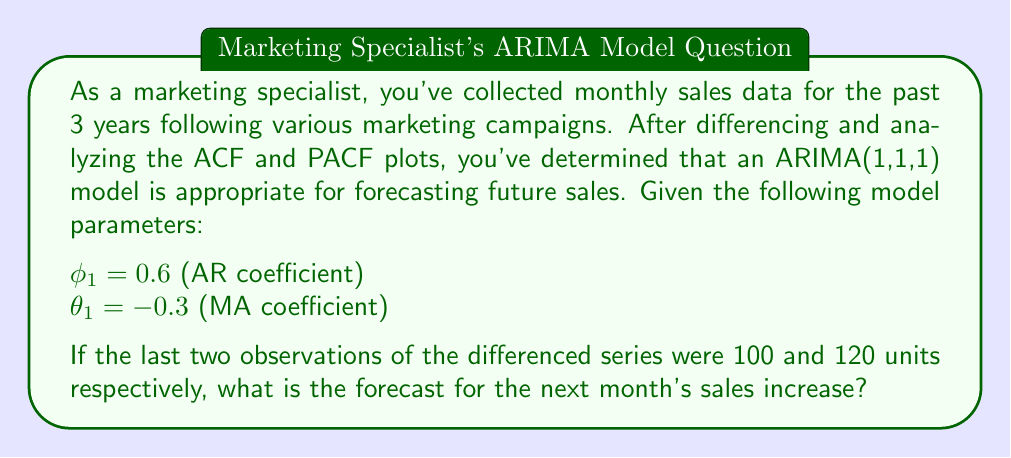Solve this math problem. To solve this problem, we'll use the ARIMA(1,1,1) model equation:

$$(1 - \phi_1B)(1-B)y_t = (1 + \theta_1B)\epsilon_t$$

Where:
- $B$ is the backshift operator
- $y_t$ is the original series
- $(1-B)y_t$ is the differenced series
- $\epsilon_t$ is the error term

For forecasting, we set all future error terms to zero. Let's denote the differenced series as $w_t = (1-B)y_t$.

The forecast equation for the differenced series becomes:

$$\hat{w}_{t+1} = \phi_1w_t + \theta_1\epsilon_t$$

We need to calculate $\epsilon_t$ using the last observation:

$$w_t = \phi_1w_{t-1} + \epsilon_t + \theta_1\epsilon_{t-1}$$
$$120 = 0.6(100) + \epsilon_t + (-0.3)\epsilon_{t-1}$$

Assuming $\epsilon_{t-1} = 0$ for simplicity:

$$120 = 60 + \epsilon_t$$
$$\epsilon_t = 60$$

Now we can forecast the next value:

$$\hat{w}_{t+1} = \phi_1w_t + \theta_1\epsilon_t$$
$$\hat{w}_{t+1} = 0.6(120) + (-0.3)(60)$$
$$\hat{w}_{t+1} = 72 - 18$$
$$\hat{w}_{t+1} = 54$$

Therefore, the forecast for the next month's sales increase is 54 units.
Answer: 54 units 